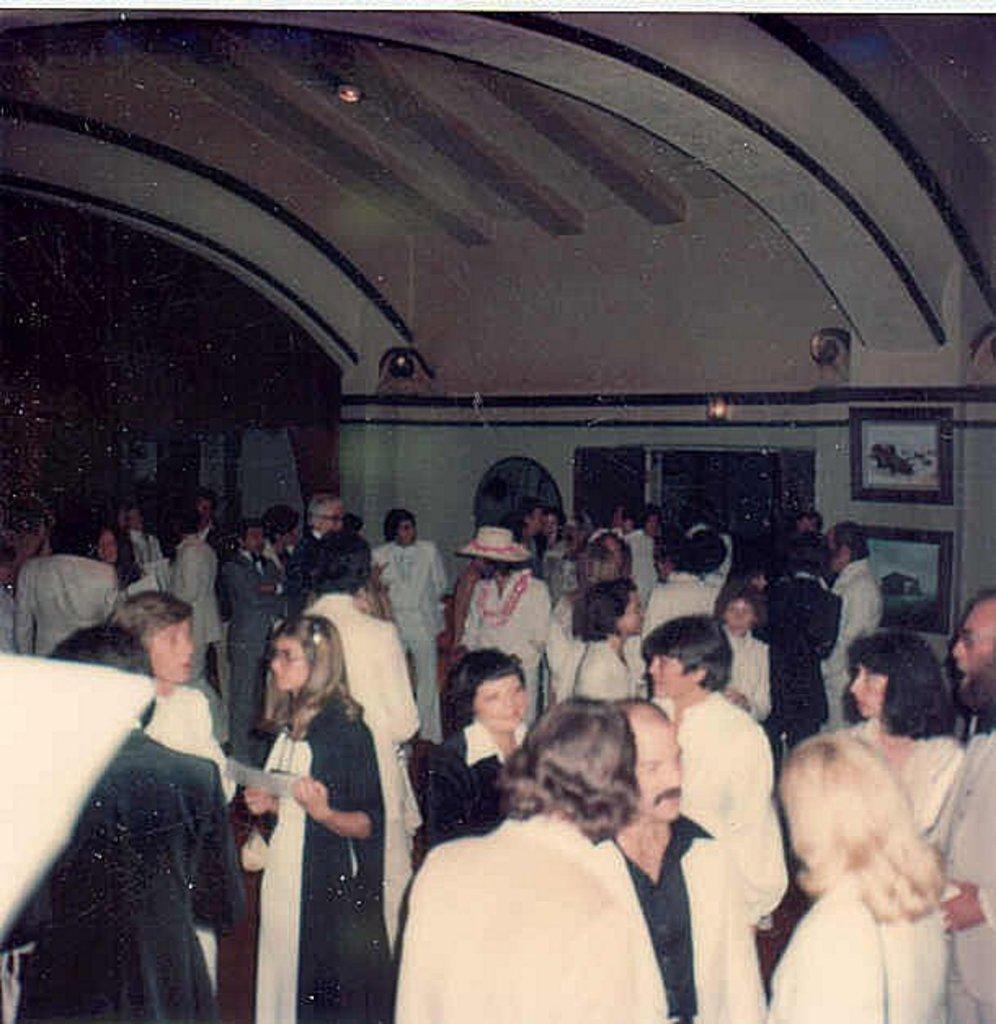How would you summarize this image in a sentence or two? In the image we can see there are many people around, standing and wearing clothes. Here we can see there are frames stick to the wall. There is a window, light and the left top of the image is dark. 